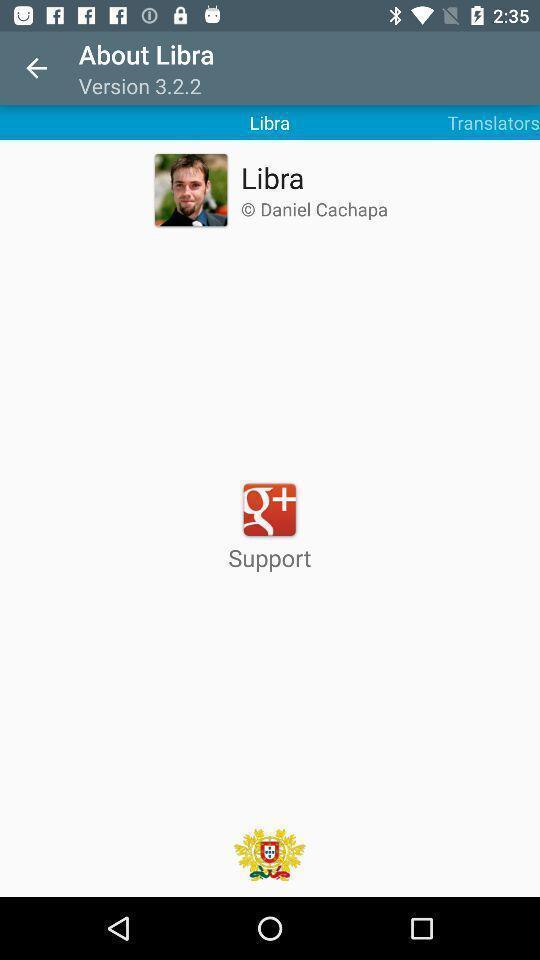Provide a description of this screenshot. Screen showing page. 